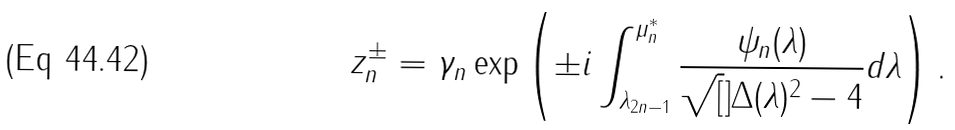Convert formula to latex. <formula><loc_0><loc_0><loc_500><loc_500>z _ { n } ^ { \pm } = \gamma _ { n } \exp \left ( \pm i \int _ { \lambda _ { 2 n - 1 } } ^ { \mu _ { n } ^ { * } } \frac { \psi _ { n } ( \lambda ) } { \sqrt { [ } ] { \Delta ( \lambda ) ^ { 2 } - 4 } } d \lambda \right ) .</formula> 